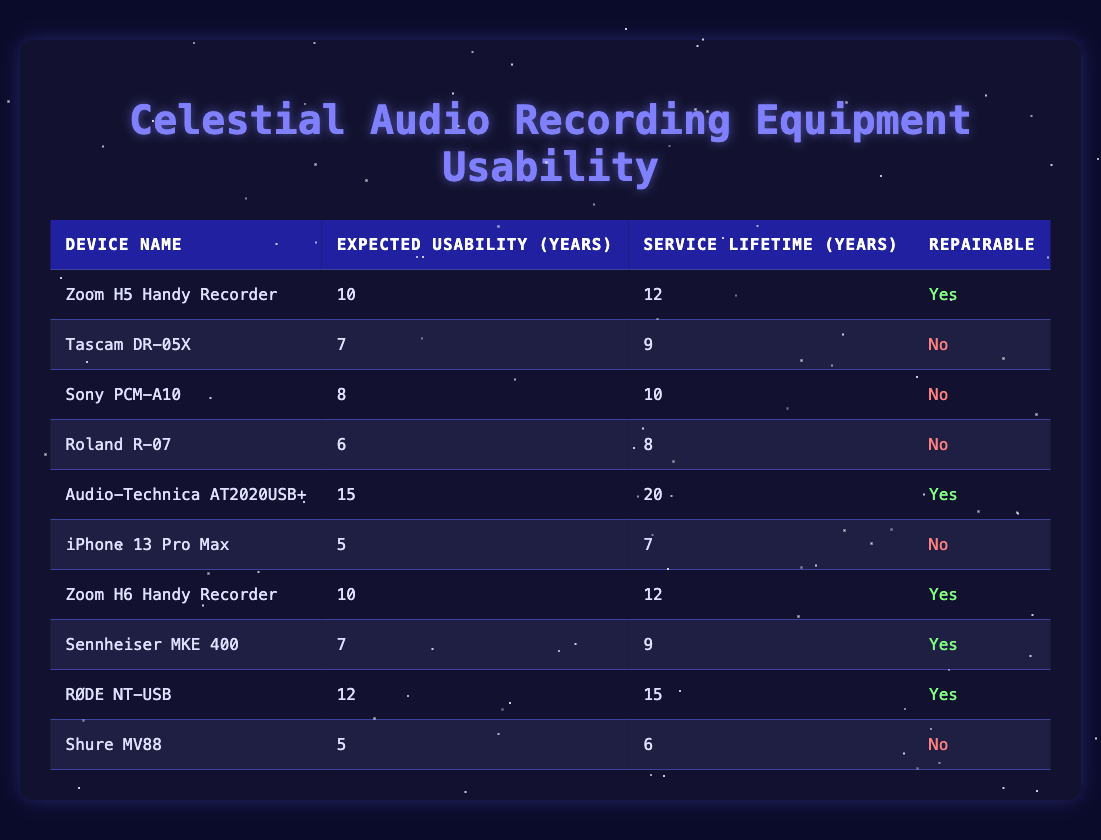What is the expected usability in years of the Audio-Technica AT2020USB+? The table lists the expected usability of the Audio-Technica AT2020USB+ as 15 years.
Answer: 15 What is the service lifetime of the RØDE NT-USB? According to the table, the service lifetime of the RØDE NT-USB is 15 years.
Answer: 15 Which devices are repairable? By checking the table, the devices marked as repairable are: Zoom H5 Handy Recorder, Audio-Technica AT2020USB+, Zoom H6 Handy Recorder, Sennheiser MKE 400, and RØDE NT-USB.
Answer: 5 devices What is the average expected usability of the non-repairable devices? The non-repairable devices are Tascam DR-05X (7), Sony PCM-A10 (8), Roland R-07 (6), iPhone 13 Pro Max (5), and Shure MV88 (5). Adding these gives 7 + 8 + 6 + 5 + 5 = 31. To find the average, divide by 5, which gives 31/5 = 6.2.
Answer: 6.2 How many devices have an expected usability above 10 years? In the table, the devices with expected usability above 10 years are: Zoom H5 Handy Recorder (10), Audio-Technica AT2020USB+ (15), and RØDE NT-USB (12). This totals to 3 devices.
Answer: 3 What is the difference between the expected usability of the Zoom H6 Handy Recorder and the iPhone 13 Pro Max? The expected usability for the Zoom H6 Handy Recorder is 10 years and for the iPhone 13 Pro Max is 5 years. The difference is 10 - 5 = 5 years.
Answer: 5 Does the Tascam DR-05X have a longer service lifetime than the Sony PCM-A10? The Tascam DR-05X has a service lifetime of 9 years and the Sony PCM-A10 has a service lifetime of 10 years. Since 9 is not greater than 10, the answer is no.
Answer: No What is the total expected usability of all repairable devices? The repairable devices and their expected usability are: Zoom H5 Handy Recorder (10), Audio-Technica AT2020USB+ (15), Zoom H6 Handy Recorder (10), Sennheiser MKE 400 (7), and RØDE NT-USB (12). Adding these gives 10 + 15 + 10 + 7 + 12 = 54.
Answer: 54 Which device has the shortest expected usability? The device with the shortest expected usability is the Shure MV88 with 5 years.
Answer: Shure MV88 